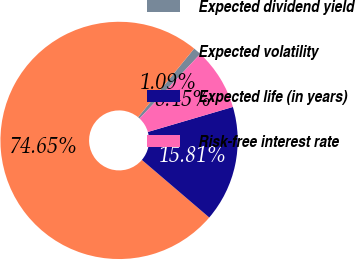Convert chart to OTSL. <chart><loc_0><loc_0><loc_500><loc_500><pie_chart><fcel>Expected dividend yield<fcel>Expected volatility<fcel>Expected life (in years)<fcel>Risk-free interest rate<nl><fcel>1.09%<fcel>74.65%<fcel>15.81%<fcel>8.45%<nl></chart> 